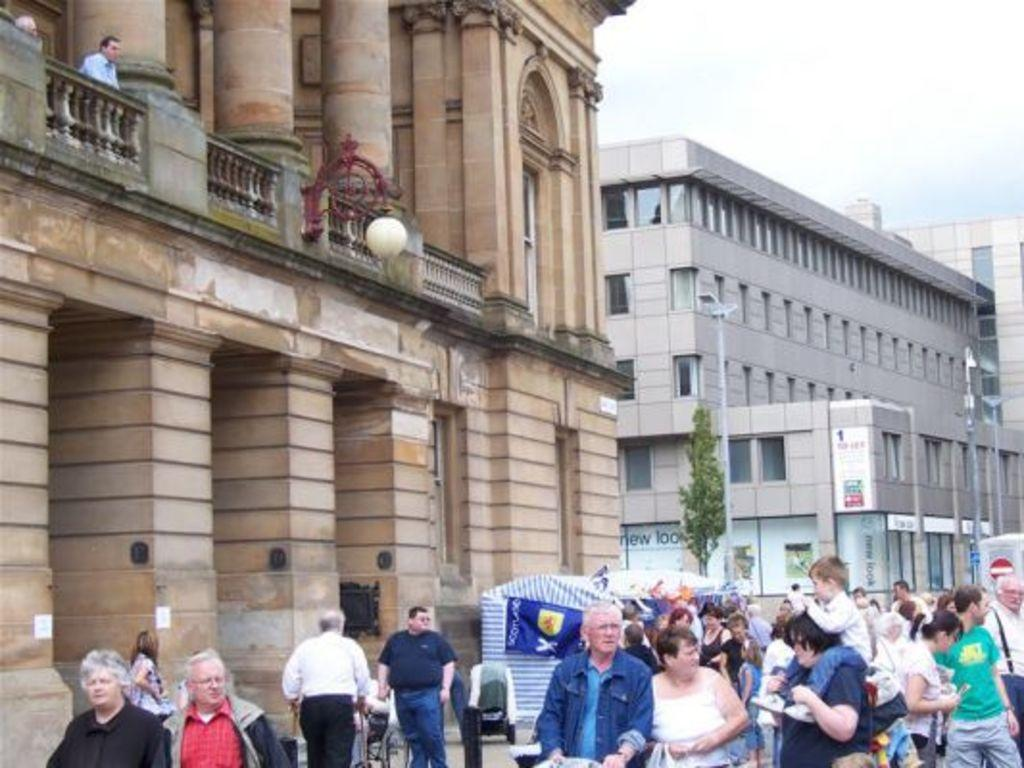How many people are in the image? There is a group of people in the image, but the exact number cannot be determined from the provided facts. What type of natural element is present in the image? There is a tree in the image. What type of shelter is visible in the image? There is a tent in the image. What type of structures can be seen in the image? There are buildings in the image. What type of vertical structures are present in the image? There are poles in the image. What type of printed materials are present in the image? There are posters in the image. What type of objects are present in the image? There are some objects in the image, but their specific nature cannot be determined from the provided facts. What is visible in the background of the image? The sky is visible in the background of the image. What type of stew is being served in the image? There is no stew present in the image. How does the car in the image affect the group of people? There is no car present in the image, so it cannot affect the group of people. 